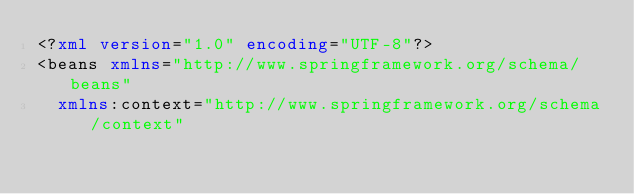<code> <loc_0><loc_0><loc_500><loc_500><_XML_><?xml version="1.0" encoding="UTF-8"?>
<beans xmlns="http://www.springframework.org/schema/beans"
	xmlns:context="http://www.springframework.org/schema/context"</code> 